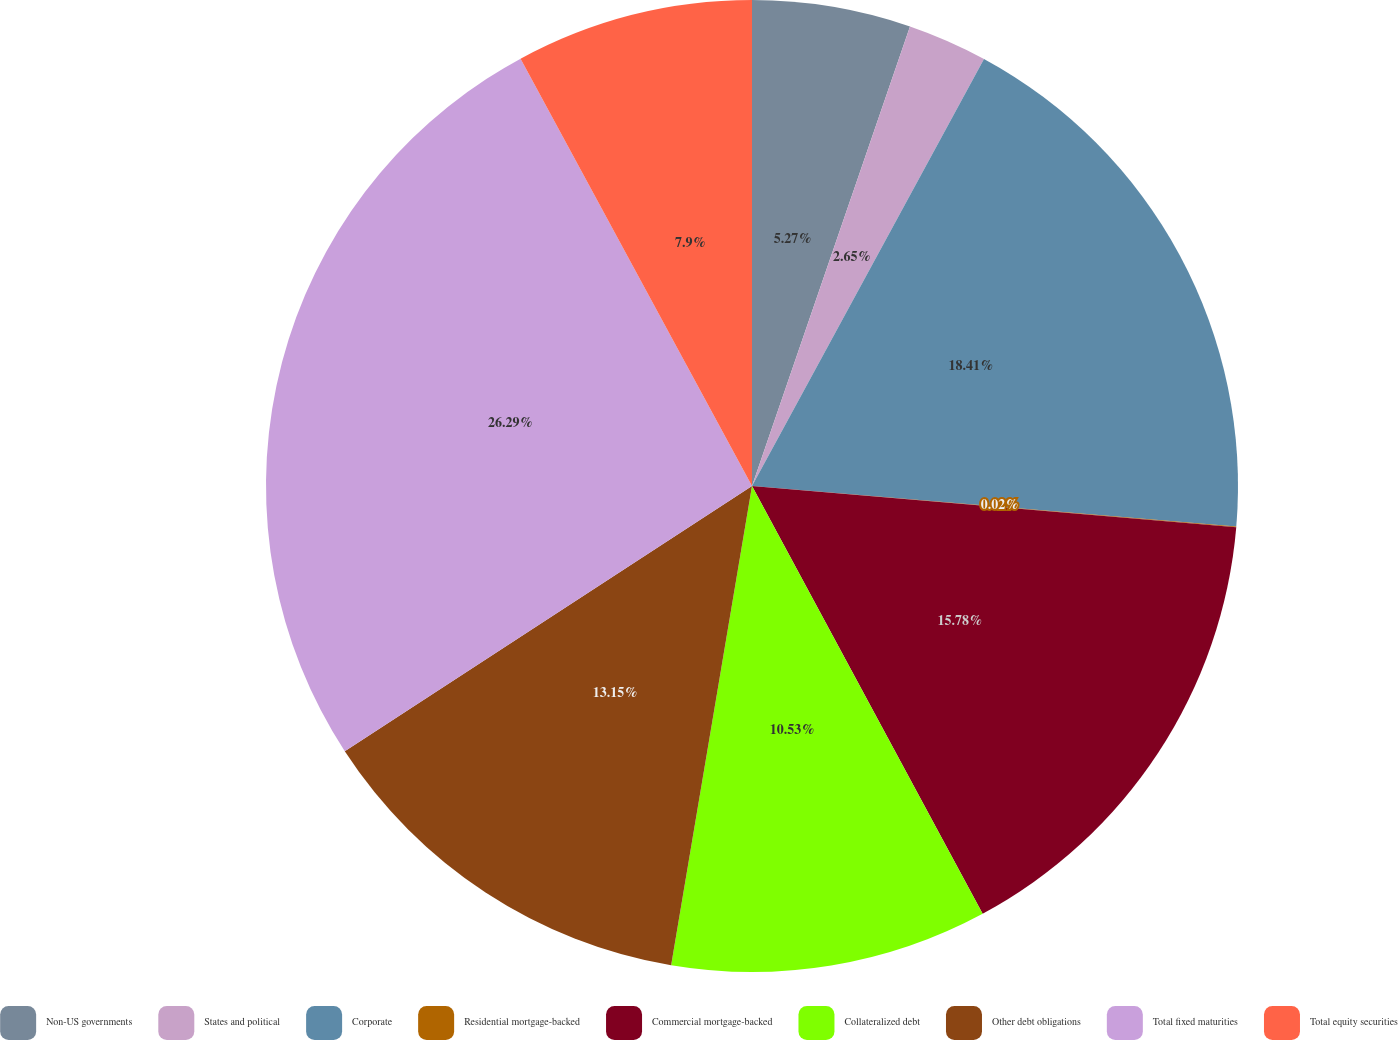<chart> <loc_0><loc_0><loc_500><loc_500><pie_chart><fcel>Non-US governments<fcel>States and political<fcel>Corporate<fcel>Residential mortgage-backed<fcel>Commercial mortgage-backed<fcel>Collateralized debt<fcel>Other debt obligations<fcel>Total fixed maturities<fcel>Total equity securities<nl><fcel>5.27%<fcel>2.65%<fcel>18.41%<fcel>0.02%<fcel>15.78%<fcel>10.53%<fcel>13.15%<fcel>26.29%<fcel>7.9%<nl></chart> 